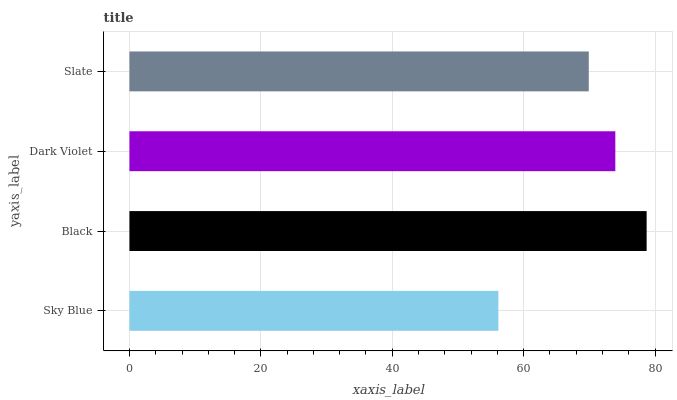Is Sky Blue the minimum?
Answer yes or no. Yes. Is Black the maximum?
Answer yes or no. Yes. Is Dark Violet the minimum?
Answer yes or no. No. Is Dark Violet the maximum?
Answer yes or no. No. Is Black greater than Dark Violet?
Answer yes or no. Yes. Is Dark Violet less than Black?
Answer yes or no. Yes. Is Dark Violet greater than Black?
Answer yes or no. No. Is Black less than Dark Violet?
Answer yes or no. No. Is Dark Violet the high median?
Answer yes or no. Yes. Is Slate the low median?
Answer yes or no. Yes. Is Sky Blue the high median?
Answer yes or no. No. Is Dark Violet the low median?
Answer yes or no. No. 